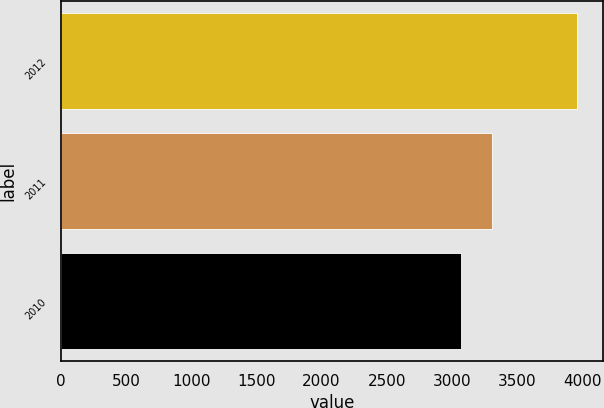Convert chart to OTSL. <chart><loc_0><loc_0><loc_500><loc_500><bar_chart><fcel>2012<fcel>2011<fcel>2010<nl><fcel>3964<fcel>3306<fcel>3067<nl></chart> 